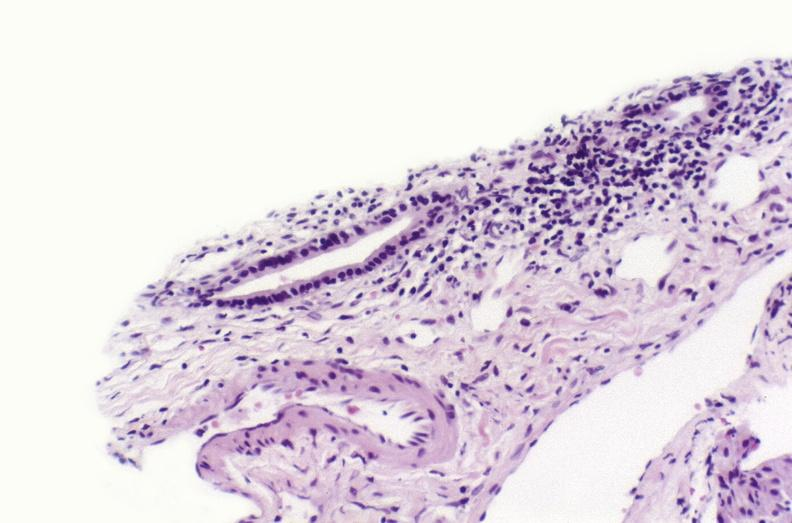does this image show sarcoid?
Answer the question using a single word or phrase. Yes 